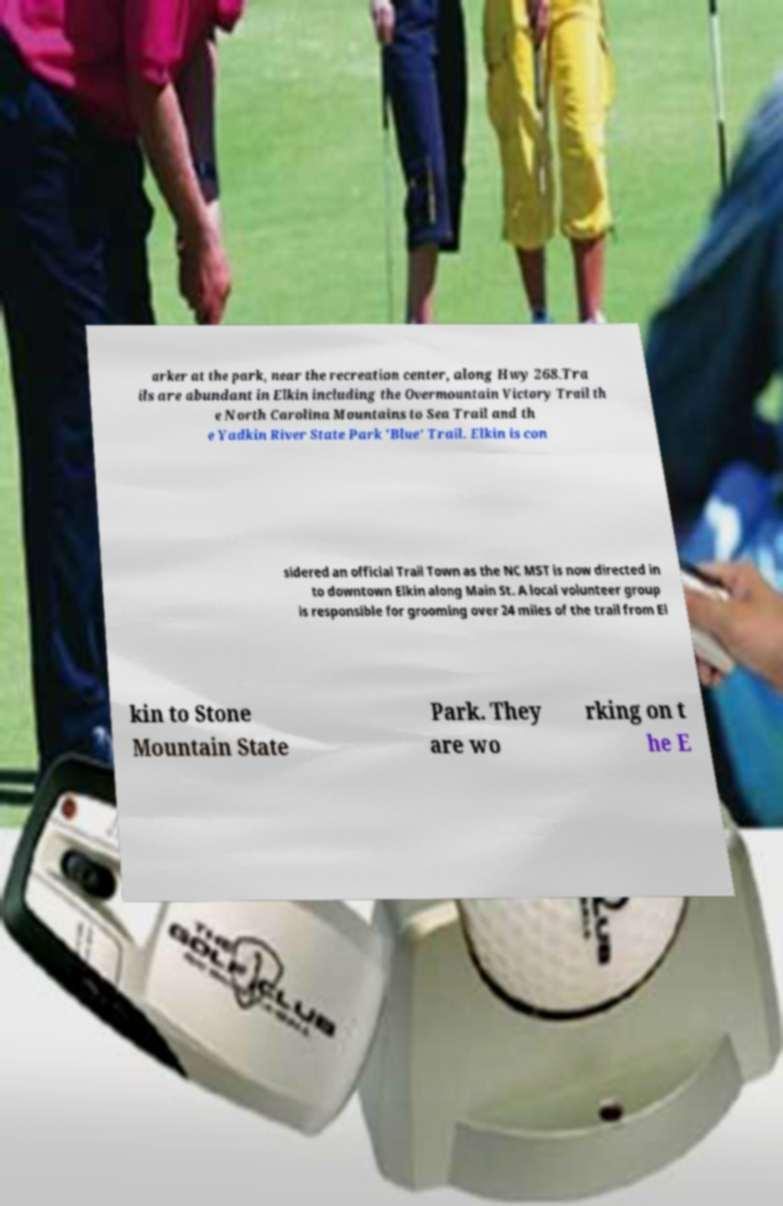Can you accurately transcribe the text from the provided image for me? arker at the park, near the recreation center, along Hwy 268.Tra ils are abundant in Elkin including the Overmountain Victory Trail th e North Carolina Mountains to Sea Trail and th e Yadkin River State Park 'Blue' Trail. Elkin is con sidered an official Trail Town as the NC MST is now directed in to downtown Elkin along Main St. A local volunteer group is responsible for grooming over 24 miles of the trail from El kin to Stone Mountain State Park. They are wo rking on t he E 